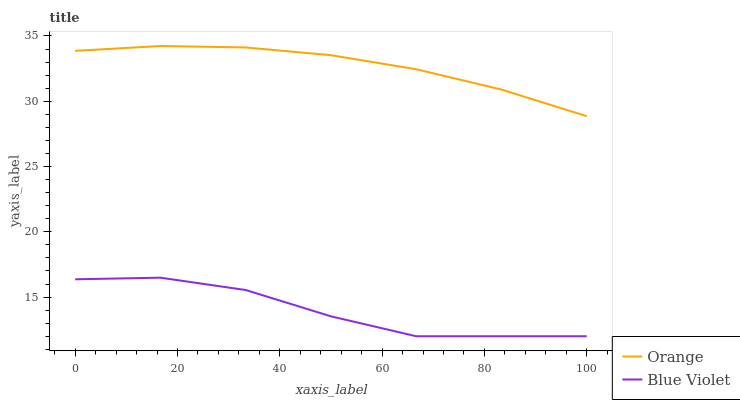Does Blue Violet have the minimum area under the curve?
Answer yes or no. Yes. Does Orange have the maximum area under the curve?
Answer yes or no. Yes. Does Blue Violet have the maximum area under the curve?
Answer yes or no. No. Is Orange the smoothest?
Answer yes or no. Yes. Is Blue Violet the roughest?
Answer yes or no. Yes. Is Blue Violet the smoothest?
Answer yes or no. No. Does Orange have the highest value?
Answer yes or no. Yes. Does Blue Violet have the highest value?
Answer yes or no. No. Is Blue Violet less than Orange?
Answer yes or no. Yes. Is Orange greater than Blue Violet?
Answer yes or no. Yes. Does Blue Violet intersect Orange?
Answer yes or no. No. 